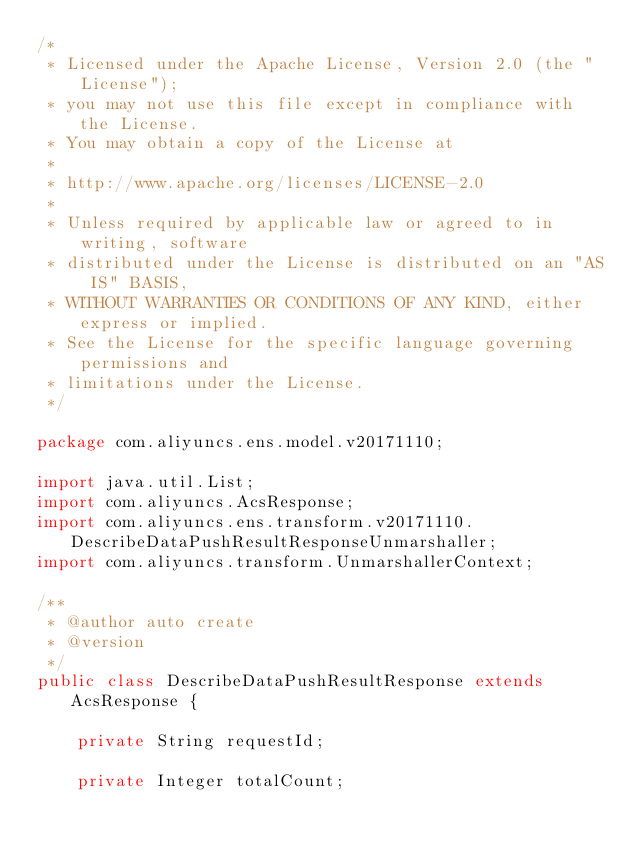Convert code to text. <code><loc_0><loc_0><loc_500><loc_500><_Java_>/*
 * Licensed under the Apache License, Version 2.0 (the "License");
 * you may not use this file except in compliance with the License.
 * You may obtain a copy of the License at
 *
 * http://www.apache.org/licenses/LICENSE-2.0
 *
 * Unless required by applicable law or agreed to in writing, software
 * distributed under the License is distributed on an "AS IS" BASIS,
 * WITHOUT WARRANTIES OR CONDITIONS OF ANY KIND, either express or implied.
 * See the License for the specific language governing permissions and
 * limitations under the License.
 */

package com.aliyuncs.ens.model.v20171110;

import java.util.List;
import com.aliyuncs.AcsResponse;
import com.aliyuncs.ens.transform.v20171110.DescribeDataPushResultResponseUnmarshaller;
import com.aliyuncs.transform.UnmarshallerContext;

/**
 * @author auto create
 * @version 
 */
public class DescribeDataPushResultResponse extends AcsResponse {

	private String requestId;

	private Integer totalCount;
</code> 